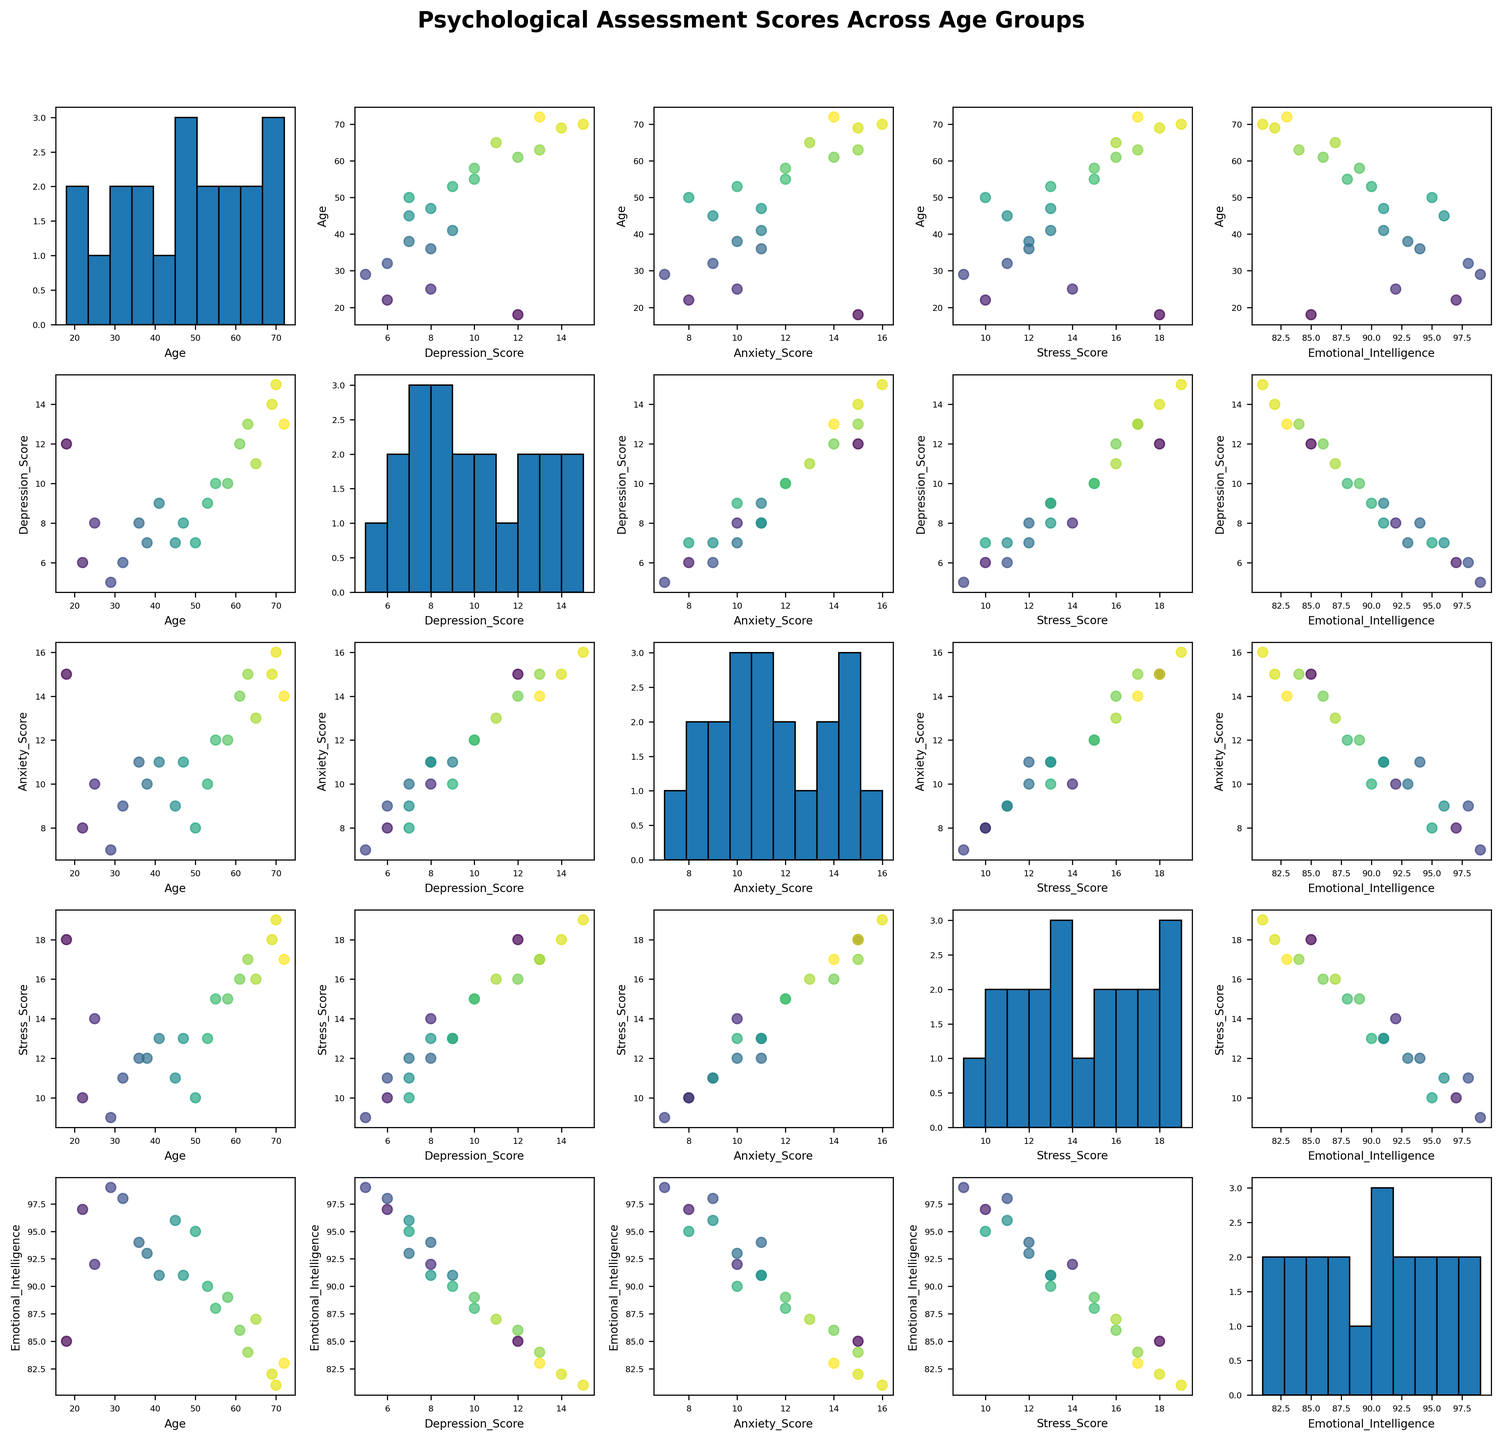What is the title of the figure? The title of the figure is written at the top of the plot. It reads "Psychological Assessment Scores Across Age Groups."
Answer: Psychological Assessment Scores Across Age Groups How many variables are illustrated in the scatterplot matrix? The scatterplot matrix contains variables which are labeled on the x and y axes. There are five labels: Age, Depression_Score, Anxiety_Score, Stress_Score, and Emotional_Intelligence.
Answer: 5 What does the color of the points represent in the scatter plots? In the scatter plots, the color of the points represents the age of the participants. This can be inferred from the use of the color map 'viridis,' which encodes age values.
Answer: Age Which variables show the highest correlation visually? Look through the scatter plots and determine which pair of variables forms a pattern that looks most like a straight line. The most linear relationship seems to be between Age and Stress_Score.
Answer: Age and Stress_Score Is there any variable that shows a strong negative correlation with Emotional Intelligence? Examine the scatter plots involving Emotional Intelligence and observe if any of them exhibit a clear downward trend. Depression_Score, Anxiety_Score, and Stress_Score do not show strong negative correlations.
Answer: No Which variable's histogram shows the highest peak? Check the diagonal of the scatterplot matrix where histograms are plotted for individual variables. Identify which histogram has the tallest bar. This is for Emotional_Intelligence.
Answer: Emotional_Intelligence What trend do you observe between Age and Emotional Intelligence? Look at the scatter plot for Age vs. Emotional_Intelligence. Observe the distribution and trend of the points. It shows a slight downward trend, indicating that Emotional Intelligence slightly decreases with Age.
Answer: Slightly negative Among age groups, which group tends to have the highest Stress Scores? To find which age group exhibits the highest Stress_Scores, locate the scatter plot with Age on one axis and Stress_Score on the other. The oldest participants (upper age groups) tend to have higher Stress_Scores.
Answer: Older age groups What is the relation between Depression_Score and Anxiety_Score? Evaluate the scatter plot that pairs Depression_Score on one axis with Anxiety_Score on the other. The pattern of points suggests that as Depression_Score increases, Anxiety_Score also tends to increase.
Answer: Positive correlation 